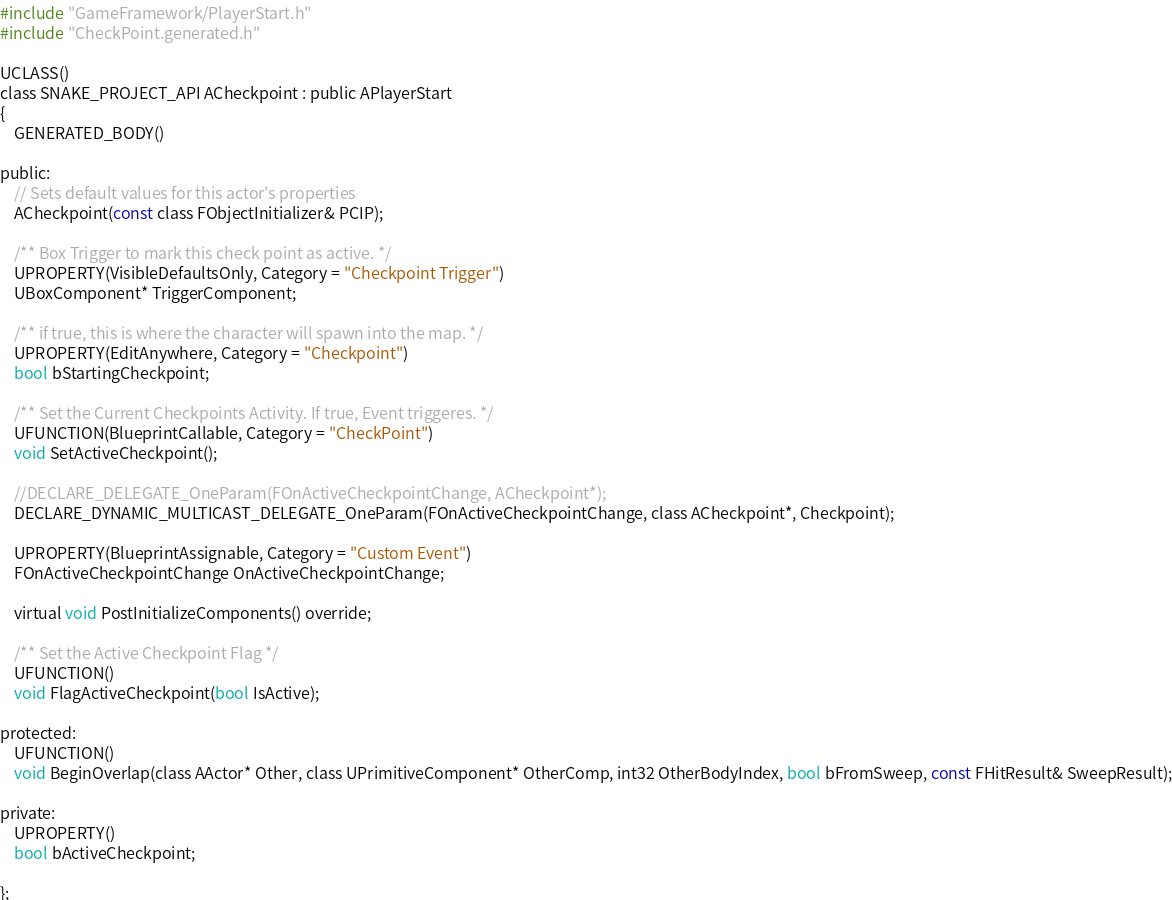Convert code to text. <code><loc_0><loc_0><loc_500><loc_500><_C_>#include "GameFramework/PlayerStart.h"
#include "CheckPoint.generated.h"

UCLASS()
class SNAKE_PROJECT_API ACheckpoint : public APlayerStart
{
	GENERATED_BODY()
	
public:	
	// Sets default values for this actor's properties
	ACheckpoint(const class FObjectInitializer& PCIP);

	/** Box Trigger to mark this check point as active. */
	UPROPERTY(VisibleDefaultsOnly, Category = "Checkpoint Trigger")
	UBoxComponent* TriggerComponent;

	/** if true, this is where the character will spawn into the map. */
	UPROPERTY(EditAnywhere, Category = "Checkpoint")
	bool bStartingCheckpoint;

	/** Set the Current Checkpoints Activity. If true, Event triggeres. */
	UFUNCTION(BlueprintCallable, Category = "CheckPoint")
	void SetActiveCheckpoint();

	//DECLARE_DELEGATE_OneParam(FOnActiveCheckpointChange, ACheckpoint*);
	DECLARE_DYNAMIC_MULTICAST_DELEGATE_OneParam(FOnActiveCheckpointChange, class ACheckpoint*, Checkpoint);

	UPROPERTY(BlueprintAssignable, Category = "Custom Event")
	FOnActiveCheckpointChange OnActiveCheckpointChange;

	virtual void PostInitializeComponents() override;

	/** Set the Active Checkpoint Flag */
	UFUNCTION()
	void FlagActiveCheckpoint(bool IsActive);

protected:
	UFUNCTION()
	void BeginOverlap(class AActor* Other, class UPrimitiveComponent* OtherComp, int32 OtherBodyIndex, bool bFromSweep, const FHitResult& SweepResult);

private:
	UPROPERTY()
	bool bActiveCheckpoint;

};
</code> 